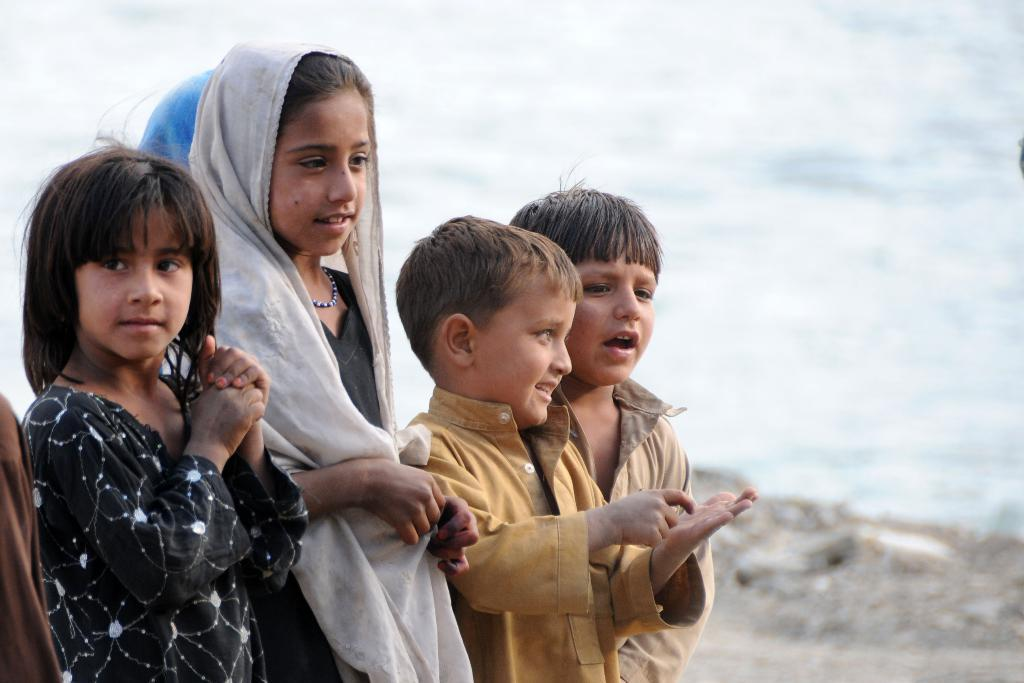How many children are present in the image? There are four children in the image, two girls and two boys. What are the children doing in the image? The children are standing. What can be seen in the background of the image? There is water visible in the background of the image. How is the image of the water depicted? The image of the water is blurry. What type of parcel is being delivered in the image? There is no parcel present in the image. 